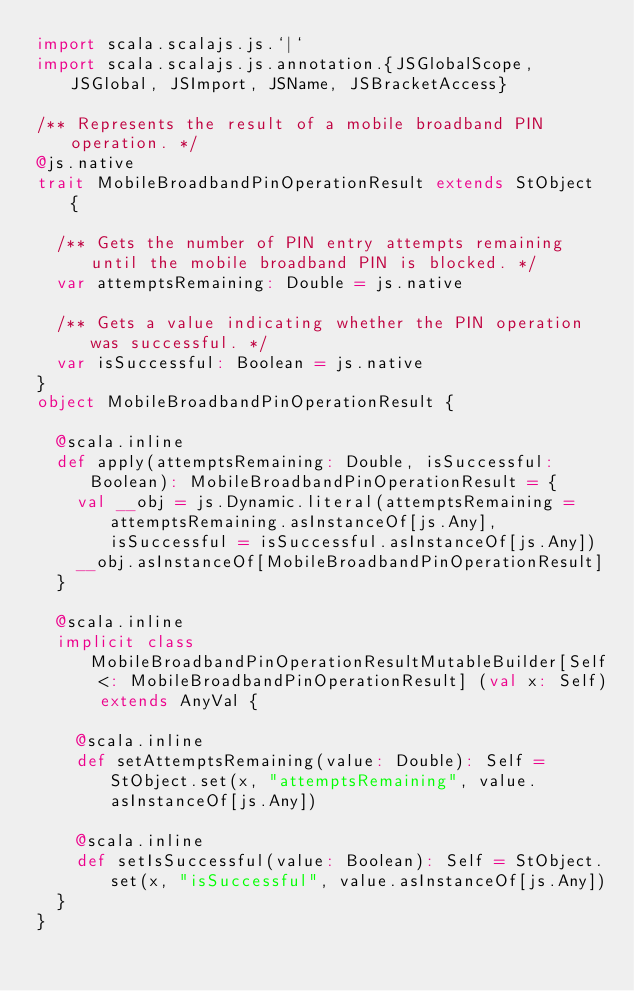Convert code to text. <code><loc_0><loc_0><loc_500><loc_500><_Scala_>import scala.scalajs.js.`|`
import scala.scalajs.js.annotation.{JSGlobalScope, JSGlobal, JSImport, JSName, JSBracketAccess}

/** Represents the result of a mobile broadband PIN operation. */
@js.native
trait MobileBroadbandPinOperationResult extends StObject {
  
  /** Gets the number of PIN entry attempts remaining until the mobile broadband PIN is blocked. */
  var attemptsRemaining: Double = js.native
  
  /** Gets a value indicating whether the PIN operation was successful. */
  var isSuccessful: Boolean = js.native
}
object MobileBroadbandPinOperationResult {
  
  @scala.inline
  def apply(attemptsRemaining: Double, isSuccessful: Boolean): MobileBroadbandPinOperationResult = {
    val __obj = js.Dynamic.literal(attemptsRemaining = attemptsRemaining.asInstanceOf[js.Any], isSuccessful = isSuccessful.asInstanceOf[js.Any])
    __obj.asInstanceOf[MobileBroadbandPinOperationResult]
  }
  
  @scala.inline
  implicit class MobileBroadbandPinOperationResultMutableBuilder[Self <: MobileBroadbandPinOperationResult] (val x: Self) extends AnyVal {
    
    @scala.inline
    def setAttemptsRemaining(value: Double): Self = StObject.set(x, "attemptsRemaining", value.asInstanceOf[js.Any])
    
    @scala.inline
    def setIsSuccessful(value: Boolean): Self = StObject.set(x, "isSuccessful", value.asInstanceOf[js.Any])
  }
}
</code> 